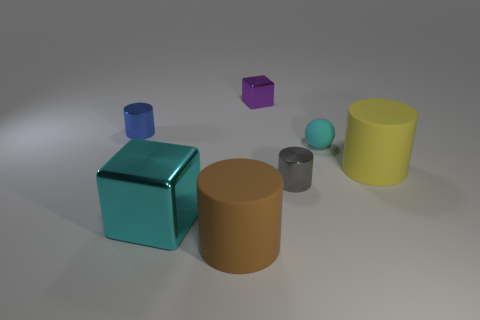There is a rubber object behind the rubber cylinder that is behind the cyan metal object; what is its size?
Your response must be concise. Small. There is a blue object that is the same material as the tiny gray object; what size is it?
Your response must be concise. Small. There is a tiny thing that is on the right side of the large block and behind the rubber sphere; what is its shape?
Offer a terse response. Cube. Are there an equal number of tiny shiny things that are to the right of the blue shiny cylinder and cyan objects?
Your response must be concise. Yes. What number of objects are either blue cylinders or rubber objects to the right of the large brown rubber object?
Your answer should be very brief. 3. Is there another metal object that has the same shape as the large cyan metallic thing?
Provide a short and direct response. Yes. Is the number of small rubber balls in front of the large brown cylinder the same as the number of cyan cubes to the left of the small blue cylinder?
Offer a terse response. Yes. How many cyan things are either cylinders or tiny cubes?
Offer a very short reply. 0. What number of brown things are the same size as the cyan shiny object?
Give a very brief answer. 1. What is the color of the large thing that is to the left of the cyan rubber thing and behind the big brown rubber cylinder?
Keep it short and to the point. Cyan. 